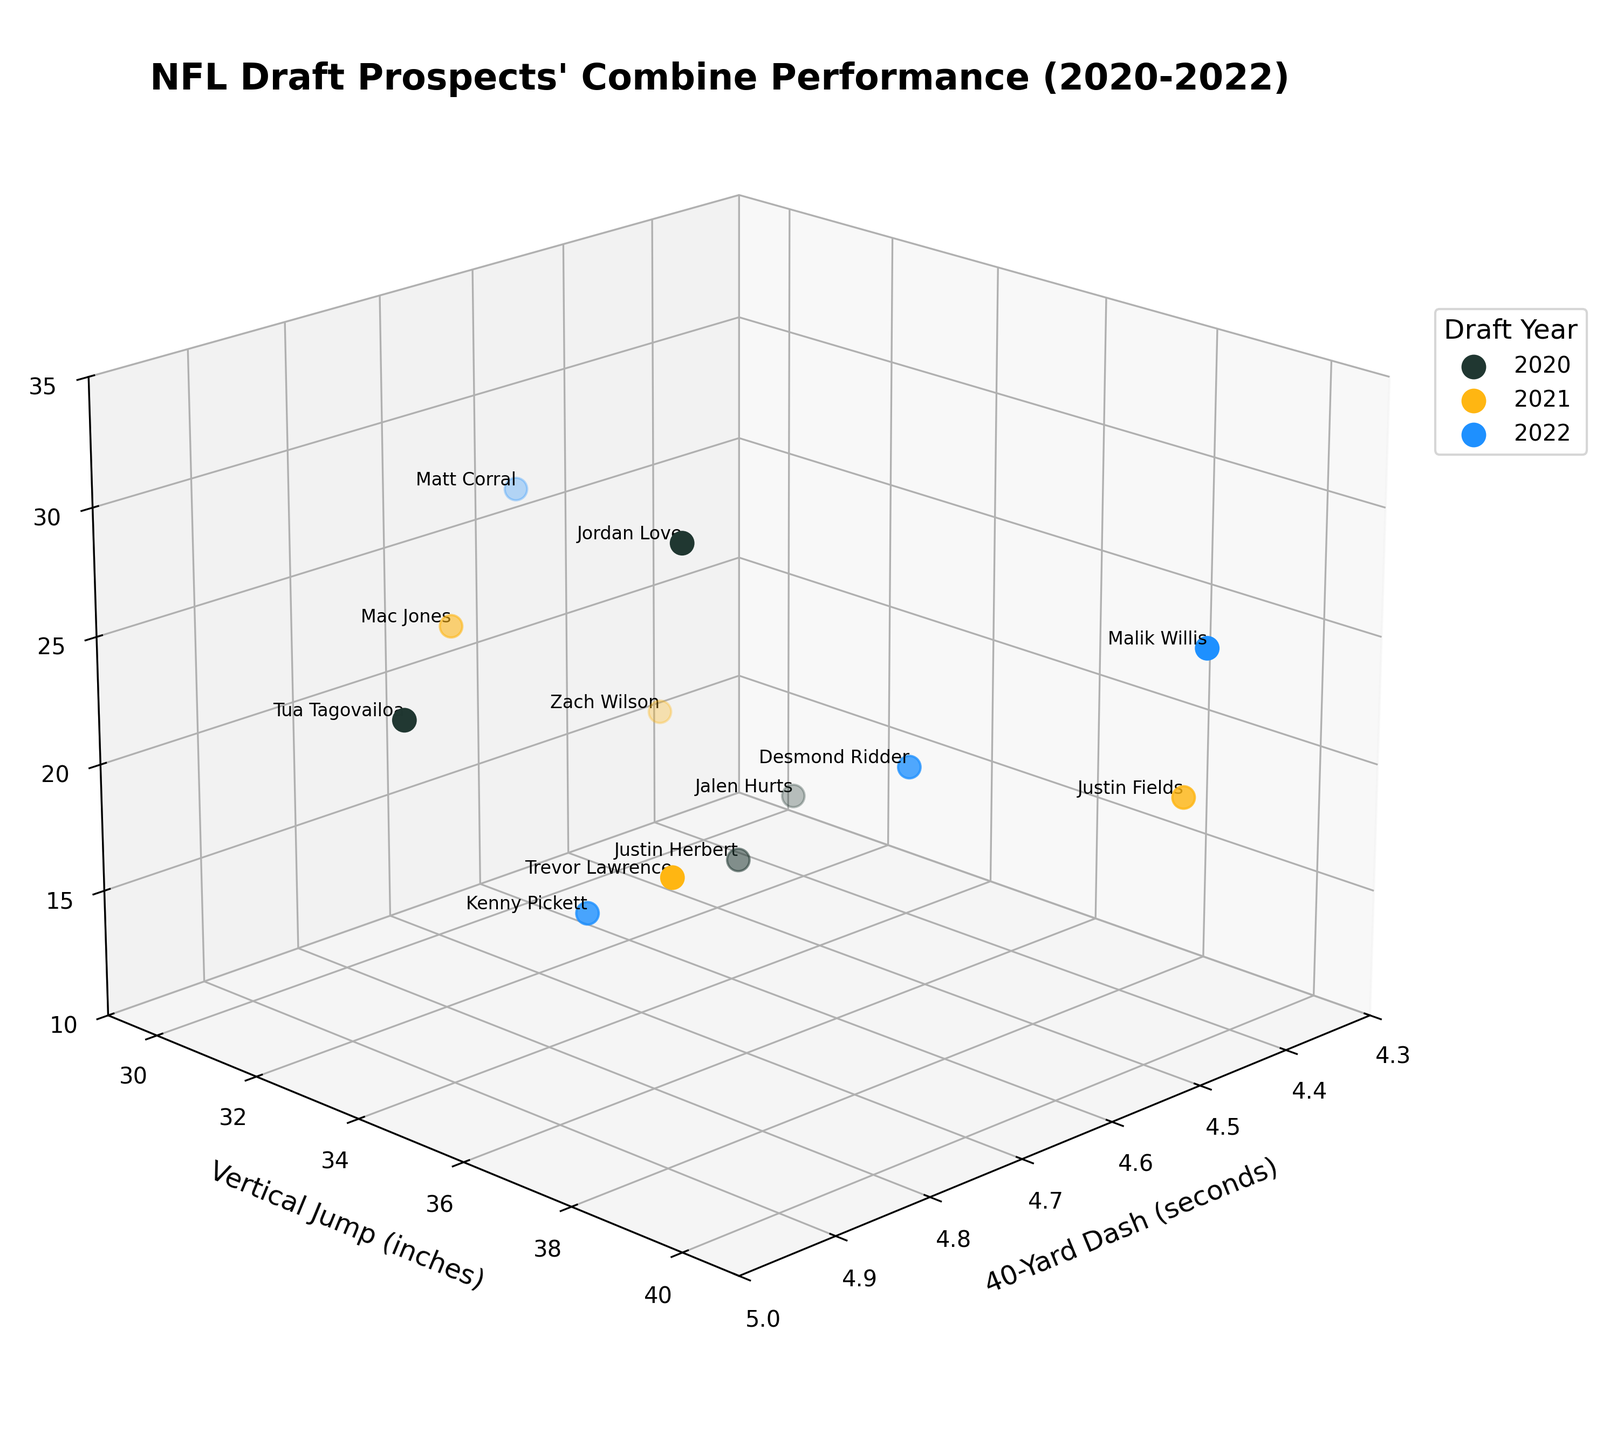What is the title of the figure? The title of the figure is typically found at the top of the plot and is designed to give a quick overview of what the plot represents. In this case, the title is "NFL Draft Prospects' Combine Performance (2020-2022)."
Answer: NFL Draft Prospects' Combine Performance (2020-2022) What are the axis labels in this plot? Axis labels are provided on the plot to describe the data dimensions represented. The x-axis label is "40-Yard Dash (seconds)," the y-axis label is "Vertical Jump (inches)," and the z-axis label is "Bench Press Reps."
Answer: 40-Yard Dash (seconds), Vertical Jump (inches), Bench Press Reps How many unique years of data are represented in the plot? By examining the color legend, we see three colors, each representing a different year. The years listed are 2020, 2021, and 2022, making a total of three unique years.
Answer: 3 Which player has the highest vertical jump in the dataset? Looking at the scatter plot, find the point that has the highest value on the y-axis (Vertical Jump). Justin Fields from 2021 has the highest vertical jump of 40 inches.
Answer: Justin Fields Who has the fastest 40-yard dash time and what is it? The fastest 40-yard dash time is found by locating the data point that is furthest to the left on the x-axis. Malik Willis from 2022 has the fastest time with 4.37 seconds.
Answer: Malik Willis, 4.37 seconds Which year had the player with the most bench press reps? Identify which player has the highest value on the z-axis (Bench Press Reps). Jordan Love from 2020 has the highest bench press reps with a count of 30.
Answer: 2020 Compare the average vertical jump values for players in 2020 and 2021. Calculate the average vertical jump for each year by summing all vertical jump values for players in that year and dividing by the number of players. For 2020: (35.5 + 35 + 35.5 + 33.5) / 4 = 34.875 inches. For 2021: (36 + 33.5 + 40 + 32) / 4 = 35.375 inches. Thus, the average vertical jump values show that 2021 has a higher average than 2020.
Answer: 2021: 35.375 inches, 2020: 34.875 inches Which players had both a vertical jump greater than 34 inches and bench press reps greater than 20? Look for players whose vertical jump exceeds 34 inches and have bench press reps greater than 20. The players meeting these criteria are Jordan Love (2020), Malik Willis (2022), Matt Corral (2022).
Answer: Jordan Love, Malik Willis, Matt Corral What is the difference in 40-yard dash times between Trevor Lawrence and Desmond Ridder? Subtract Trevor Lawrence's 40-yard dash time from Desmond Ridder's. Trevor Lawrence's time is 4.78 seconds, and Desmond Ridder's time is 4.52 seconds. 4.78 - 4.52 = 0.26 seconds.
Answer: 0.26 seconds Which player from the 2022 draft class had the least bench press reps, and how does his vertical jump compare to the player with the most bench press reps from the same year? Identify the player from 2022 with the least bench press reps, which is Kenny Pickett with 14 reps. Compare his vertical jump (33.5 inches) to the player with the most bench press reps, Matt Corral, who had 27 reps and a vertical jump of 30 inches. Thus, Kenny Pickett's vertical jump is 3.5 inches higher.
Answer: Kenny Pickett, 3.5 inches higher 